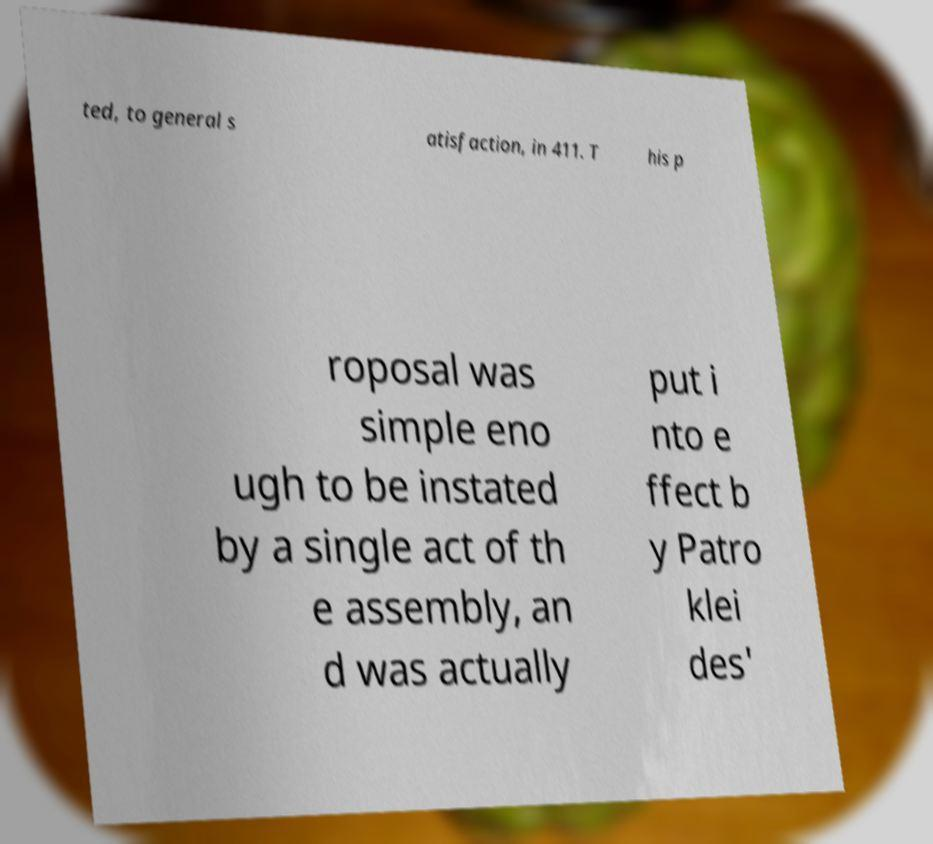Could you extract and type out the text from this image? ted, to general s atisfaction, in 411. T his p roposal was simple eno ugh to be instated by a single act of th e assembly, an d was actually put i nto e ffect b y Patro klei des' 